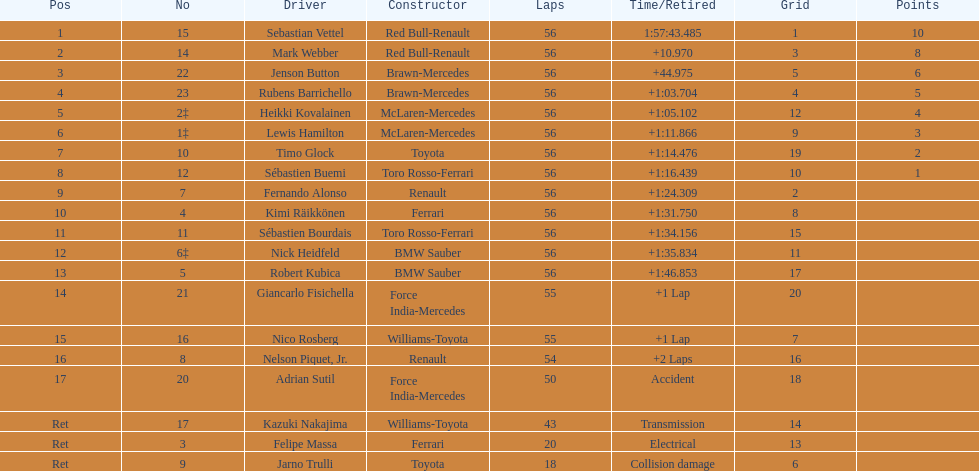Can you provide a list of all drivers? Sebastian Vettel, Mark Webber, Jenson Button, Rubens Barrichello, Heikki Kovalainen, Lewis Hamilton, Timo Glock, Sébastien Buemi, Fernando Alonso, Kimi Räikkönen, Sébastien Bourdais, Nick Heidfeld, Robert Kubica, Giancarlo Fisichella, Nico Rosberg, Nelson Piquet, Jr., Adrian Sutil, Kazuki Nakajima, Felipe Massa, Jarno Trulli. Which ones did not have ferrari as their constructor? Sebastian Vettel, Mark Webber, Jenson Button, Rubens Barrichello, Heikki Kovalainen, Lewis Hamilton, Timo Glock, Sébastien Buemi, Fernando Alonso, Sébastien Bourdais, Nick Heidfeld, Robert Kubica, Giancarlo Fisichella, Nico Rosberg, Nelson Piquet, Jr., Adrian Sutil, Kazuki Nakajima, Jarno Trulli. Who finished in the top spot? Sebastian Vettel. 